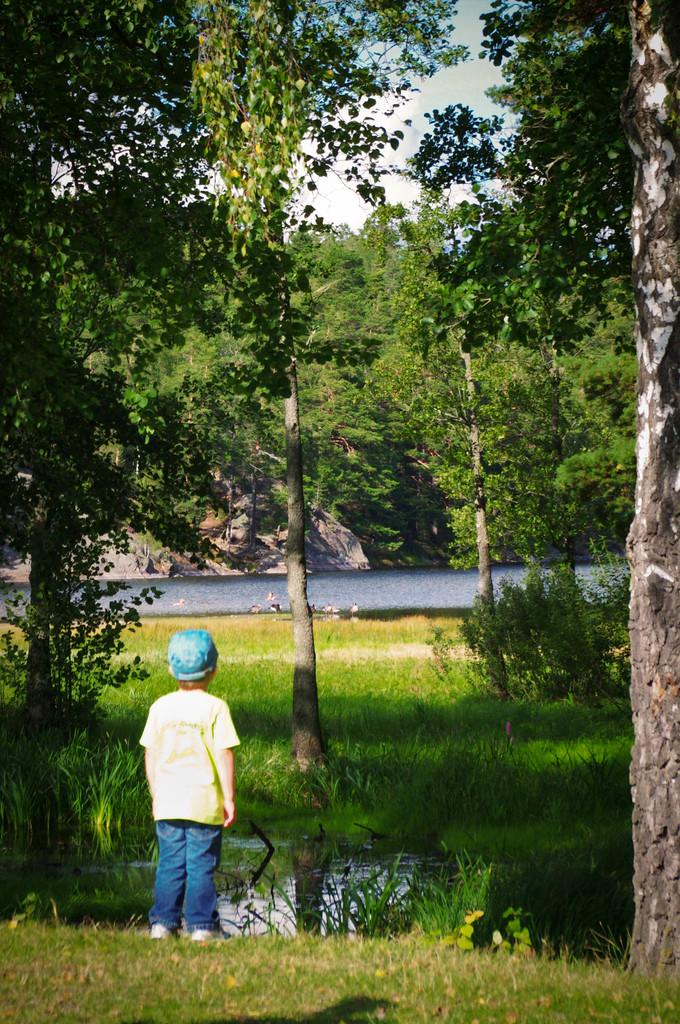What is the main subject of the image? The main subject of the image is a kid standing. What is the kid wearing on their head? The kid is wearing a cap. What type of natural environment is visible in the image? There is grass, plants, and trees visible in the image. What can be seen in the background of the image? The sky is visible in the background of the image. How many sisters are standing next to the kid in the image? There is no mention of any sisters in the image; only the kid is visible. What type of metal can be seen in the image? There is no metal, such as zinc, present in the image. 